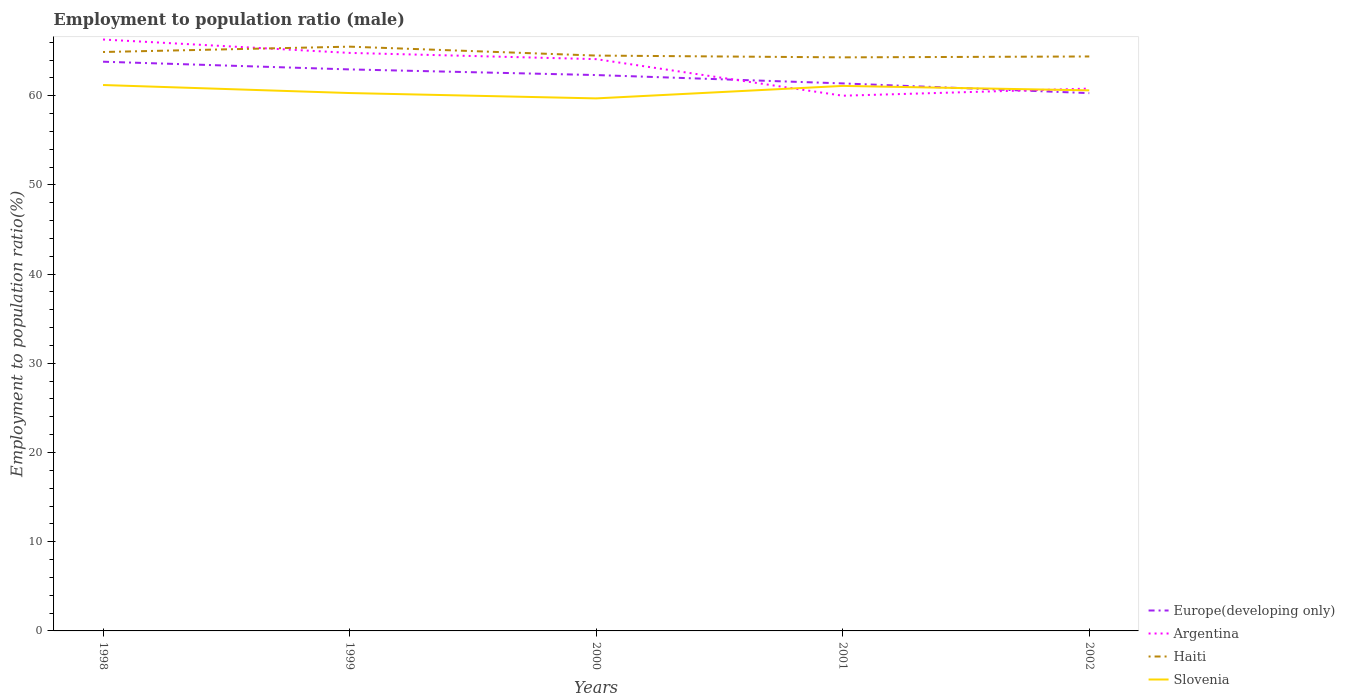How many different coloured lines are there?
Keep it short and to the point. 4. Does the line corresponding to Europe(developing only) intersect with the line corresponding to Haiti?
Provide a succinct answer. No. Across all years, what is the maximum employment to population ratio in Haiti?
Provide a short and direct response. 64.3. What is the total employment to population ratio in Haiti in the graph?
Offer a terse response. -0.6. What is the difference between the highest and the second highest employment to population ratio in Slovenia?
Give a very brief answer. 1.5. Is the employment to population ratio in Argentina strictly greater than the employment to population ratio in Haiti over the years?
Offer a very short reply. No. How many years are there in the graph?
Keep it short and to the point. 5. Does the graph contain any zero values?
Provide a short and direct response. No. Does the graph contain grids?
Ensure brevity in your answer.  No. How many legend labels are there?
Give a very brief answer. 4. How are the legend labels stacked?
Ensure brevity in your answer.  Vertical. What is the title of the graph?
Your answer should be compact. Employment to population ratio (male). Does "Russian Federation" appear as one of the legend labels in the graph?
Provide a succinct answer. No. What is the label or title of the X-axis?
Offer a very short reply. Years. What is the Employment to population ratio(%) of Europe(developing only) in 1998?
Provide a succinct answer. 63.81. What is the Employment to population ratio(%) of Argentina in 1998?
Offer a very short reply. 66.3. What is the Employment to population ratio(%) in Haiti in 1998?
Offer a very short reply. 64.9. What is the Employment to population ratio(%) in Slovenia in 1998?
Your response must be concise. 61.2. What is the Employment to population ratio(%) in Europe(developing only) in 1999?
Your response must be concise. 62.95. What is the Employment to population ratio(%) in Argentina in 1999?
Give a very brief answer. 64.8. What is the Employment to population ratio(%) of Haiti in 1999?
Provide a short and direct response. 65.5. What is the Employment to population ratio(%) of Slovenia in 1999?
Your answer should be very brief. 60.3. What is the Employment to population ratio(%) of Europe(developing only) in 2000?
Your response must be concise. 62.32. What is the Employment to population ratio(%) of Argentina in 2000?
Make the answer very short. 64.1. What is the Employment to population ratio(%) of Haiti in 2000?
Make the answer very short. 64.5. What is the Employment to population ratio(%) of Slovenia in 2000?
Provide a succinct answer. 59.7. What is the Employment to population ratio(%) of Europe(developing only) in 2001?
Your response must be concise. 61.38. What is the Employment to population ratio(%) of Haiti in 2001?
Offer a terse response. 64.3. What is the Employment to population ratio(%) of Slovenia in 2001?
Ensure brevity in your answer.  61.1. What is the Employment to population ratio(%) in Europe(developing only) in 2002?
Your answer should be compact. 60.29. What is the Employment to population ratio(%) in Argentina in 2002?
Your answer should be compact. 60.8. What is the Employment to population ratio(%) of Haiti in 2002?
Give a very brief answer. 64.4. What is the Employment to population ratio(%) in Slovenia in 2002?
Make the answer very short. 60.6. Across all years, what is the maximum Employment to population ratio(%) in Europe(developing only)?
Give a very brief answer. 63.81. Across all years, what is the maximum Employment to population ratio(%) of Argentina?
Keep it short and to the point. 66.3. Across all years, what is the maximum Employment to population ratio(%) of Haiti?
Your answer should be very brief. 65.5. Across all years, what is the maximum Employment to population ratio(%) in Slovenia?
Make the answer very short. 61.2. Across all years, what is the minimum Employment to population ratio(%) of Europe(developing only)?
Your response must be concise. 60.29. Across all years, what is the minimum Employment to population ratio(%) in Argentina?
Offer a very short reply. 60. Across all years, what is the minimum Employment to population ratio(%) in Haiti?
Offer a very short reply. 64.3. Across all years, what is the minimum Employment to population ratio(%) of Slovenia?
Offer a terse response. 59.7. What is the total Employment to population ratio(%) of Europe(developing only) in the graph?
Offer a terse response. 310.75. What is the total Employment to population ratio(%) in Argentina in the graph?
Your response must be concise. 316. What is the total Employment to population ratio(%) of Haiti in the graph?
Offer a very short reply. 323.6. What is the total Employment to population ratio(%) of Slovenia in the graph?
Offer a terse response. 302.9. What is the difference between the Employment to population ratio(%) of Europe(developing only) in 1998 and that in 1999?
Keep it short and to the point. 0.86. What is the difference between the Employment to population ratio(%) in Haiti in 1998 and that in 1999?
Your answer should be compact. -0.6. What is the difference between the Employment to population ratio(%) of Europe(developing only) in 1998 and that in 2000?
Keep it short and to the point. 1.5. What is the difference between the Employment to population ratio(%) in Argentina in 1998 and that in 2000?
Make the answer very short. 2.2. What is the difference between the Employment to population ratio(%) of Europe(developing only) in 1998 and that in 2001?
Give a very brief answer. 2.43. What is the difference between the Employment to population ratio(%) of Argentina in 1998 and that in 2001?
Make the answer very short. 6.3. What is the difference between the Employment to population ratio(%) in Haiti in 1998 and that in 2001?
Your response must be concise. 0.6. What is the difference between the Employment to population ratio(%) of Slovenia in 1998 and that in 2001?
Provide a succinct answer. 0.1. What is the difference between the Employment to population ratio(%) of Europe(developing only) in 1998 and that in 2002?
Your response must be concise. 3.52. What is the difference between the Employment to population ratio(%) of Argentina in 1998 and that in 2002?
Make the answer very short. 5.5. What is the difference between the Employment to population ratio(%) of Europe(developing only) in 1999 and that in 2000?
Offer a terse response. 0.63. What is the difference between the Employment to population ratio(%) of Argentina in 1999 and that in 2000?
Provide a succinct answer. 0.7. What is the difference between the Employment to population ratio(%) of Europe(developing only) in 1999 and that in 2001?
Keep it short and to the point. 1.57. What is the difference between the Employment to population ratio(%) of Argentina in 1999 and that in 2001?
Offer a terse response. 4.8. What is the difference between the Employment to population ratio(%) of Slovenia in 1999 and that in 2001?
Offer a terse response. -0.8. What is the difference between the Employment to population ratio(%) in Europe(developing only) in 1999 and that in 2002?
Ensure brevity in your answer.  2.66. What is the difference between the Employment to population ratio(%) of Argentina in 1999 and that in 2002?
Your answer should be very brief. 4. What is the difference between the Employment to population ratio(%) of Haiti in 1999 and that in 2002?
Provide a succinct answer. 1.1. What is the difference between the Employment to population ratio(%) of Europe(developing only) in 2000 and that in 2001?
Provide a short and direct response. 0.94. What is the difference between the Employment to population ratio(%) of Argentina in 2000 and that in 2001?
Offer a terse response. 4.1. What is the difference between the Employment to population ratio(%) in Haiti in 2000 and that in 2001?
Your answer should be very brief. 0.2. What is the difference between the Employment to population ratio(%) of Slovenia in 2000 and that in 2001?
Make the answer very short. -1.4. What is the difference between the Employment to population ratio(%) in Europe(developing only) in 2000 and that in 2002?
Your answer should be compact. 2.03. What is the difference between the Employment to population ratio(%) of Argentina in 2000 and that in 2002?
Offer a very short reply. 3.3. What is the difference between the Employment to population ratio(%) in Haiti in 2000 and that in 2002?
Keep it short and to the point. 0.1. What is the difference between the Employment to population ratio(%) of Slovenia in 2000 and that in 2002?
Your answer should be compact. -0.9. What is the difference between the Employment to population ratio(%) of Europe(developing only) in 2001 and that in 2002?
Ensure brevity in your answer.  1.09. What is the difference between the Employment to population ratio(%) in Argentina in 2001 and that in 2002?
Offer a very short reply. -0.8. What is the difference between the Employment to population ratio(%) in Haiti in 2001 and that in 2002?
Ensure brevity in your answer.  -0.1. What is the difference between the Employment to population ratio(%) in Slovenia in 2001 and that in 2002?
Provide a short and direct response. 0.5. What is the difference between the Employment to population ratio(%) in Europe(developing only) in 1998 and the Employment to population ratio(%) in Argentina in 1999?
Make the answer very short. -0.99. What is the difference between the Employment to population ratio(%) of Europe(developing only) in 1998 and the Employment to population ratio(%) of Haiti in 1999?
Offer a terse response. -1.69. What is the difference between the Employment to population ratio(%) of Europe(developing only) in 1998 and the Employment to population ratio(%) of Slovenia in 1999?
Your response must be concise. 3.51. What is the difference between the Employment to population ratio(%) in Europe(developing only) in 1998 and the Employment to population ratio(%) in Argentina in 2000?
Offer a terse response. -0.29. What is the difference between the Employment to population ratio(%) in Europe(developing only) in 1998 and the Employment to population ratio(%) in Haiti in 2000?
Your answer should be compact. -0.69. What is the difference between the Employment to population ratio(%) in Europe(developing only) in 1998 and the Employment to population ratio(%) in Slovenia in 2000?
Ensure brevity in your answer.  4.11. What is the difference between the Employment to population ratio(%) of Europe(developing only) in 1998 and the Employment to population ratio(%) of Argentina in 2001?
Give a very brief answer. 3.81. What is the difference between the Employment to population ratio(%) of Europe(developing only) in 1998 and the Employment to population ratio(%) of Haiti in 2001?
Your answer should be very brief. -0.49. What is the difference between the Employment to population ratio(%) of Europe(developing only) in 1998 and the Employment to population ratio(%) of Slovenia in 2001?
Your answer should be very brief. 2.71. What is the difference between the Employment to population ratio(%) in Argentina in 1998 and the Employment to population ratio(%) in Haiti in 2001?
Offer a terse response. 2. What is the difference between the Employment to population ratio(%) in Europe(developing only) in 1998 and the Employment to population ratio(%) in Argentina in 2002?
Provide a short and direct response. 3.01. What is the difference between the Employment to population ratio(%) of Europe(developing only) in 1998 and the Employment to population ratio(%) of Haiti in 2002?
Keep it short and to the point. -0.59. What is the difference between the Employment to population ratio(%) in Europe(developing only) in 1998 and the Employment to population ratio(%) in Slovenia in 2002?
Offer a very short reply. 3.21. What is the difference between the Employment to population ratio(%) of Argentina in 1998 and the Employment to population ratio(%) of Slovenia in 2002?
Provide a short and direct response. 5.7. What is the difference between the Employment to population ratio(%) in Haiti in 1998 and the Employment to population ratio(%) in Slovenia in 2002?
Give a very brief answer. 4.3. What is the difference between the Employment to population ratio(%) of Europe(developing only) in 1999 and the Employment to population ratio(%) of Argentina in 2000?
Your answer should be very brief. -1.15. What is the difference between the Employment to population ratio(%) in Europe(developing only) in 1999 and the Employment to population ratio(%) in Haiti in 2000?
Your answer should be very brief. -1.55. What is the difference between the Employment to population ratio(%) in Europe(developing only) in 1999 and the Employment to population ratio(%) in Slovenia in 2000?
Your answer should be compact. 3.25. What is the difference between the Employment to population ratio(%) in Argentina in 1999 and the Employment to population ratio(%) in Haiti in 2000?
Offer a terse response. 0.3. What is the difference between the Employment to population ratio(%) of Argentina in 1999 and the Employment to population ratio(%) of Slovenia in 2000?
Make the answer very short. 5.1. What is the difference between the Employment to population ratio(%) of Haiti in 1999 and the Employment to population ratio(%) of Slovenia in 2000?
Your answer should be compact. 5.8. What is the difference between the Employment to population ratio(%) in Europe(developing only) in 1999 and the Employment to population ratio(%) in Argentina in 2001?
Ensure brevity in your answer.  2.95. What is the difference between the Employment to population ratio(%) of Europe(developing only) in 1999 and the Employment to population ratio(%) of Haiti in 2001?
Give a very brief answer. -1.35. What is the difference between the Employment to population ratio(%) of Europe(developing only) in 1999 and the Employment to population ratio(%) of Slovenia in 2001?
Offer a very short reply. 1.85. What is the difference between the Employment to population ratio(%) of Argentina in 1999 and the Employment to population ratio(%) of Haiti in 2001?
Your answer should be very brief. 0.5. What is the difference between the Employment to population ratio(%) of Europe(developing only) in 1999 and the Employment to population ratio(%) of Argentina in 2002?
Your response must be concise. 2.15. What is the difference between the Employment to population ratio(%) of Europe(developing only) in 1999 and the Employment to population ratio(%) of Haiti in 2002?
Your answer should be very brief. -1.45. What is the difference between the Employment to population ratio(%) in Europe(developing only) in 1999 and the Employment to population ratio(%) in Slovenia in 2002?
Ensure brevity in your answer.  2.35. What is the difference between the Employment to population ratio(%) of Argentina in 1999 and the Employment to population ratio(%) of Haiti in 2002?
Provide a short and direct response. 0.4. What is the difference between the Employment to population ratio(%) of Haiti in 1999 and the Employment to population ratio(%) of Slovenia in 2002?
Provide a short and direct response. 4.9. What is the difference between the Employment to population ratio(%) of Europe(developing only) in 2000 and the Employment to population ratio(%) of Argentina in 2001?
Provide a short and direct response. 2.32. What is the difference between the Employment to population ratio(%) of Europe(developing only) in 2000 and the Employment to population ratio(%) of Haiti in 2001?
Provide a short and direct response. -1.98. What is the difference between the Employment to population ratio(%) of Europe(developing only) in 2000 and the Employment to population ratio(%) of Slovenia in 2001?
Ensure brevity in your answer.  1.22. What is the difference between the Employment to population ratio(%) of Europe(developing only) in 2000 and the Employment to population ratio(%) of Argentina in 2002?
Give a very brief answer. 1.52. What is the difference between the Employment to population ratio(%) of Europe(developing only) in 2000 and the Employment to population ratio(%) of Haiti in 2002?
Keep it short and to the point. -2.08. What is the difference between the Employment to population ratio(%) of Europe(developing only) in 2000 and the Employment to population ratio(%) of Slovenia in 2002?
Make the answer very short. 1.72. What is the difference between the Employment to population ratio(%) of Argentina in 2000 and the Employment to population ratio(%) of Haiti in 2002?
Your answer should be very brief. -0.3. What is the difference between the Employment to population ratio(%) in Argentina in 2000 and the Employment to population ratio(%) in Slovenia in 2002?
Provide a succinct answer. 3.5. What is the difference between the Employment to population ratio(%) of Europe(developing only) in 2001 and the Employment to population ratio(%) of Argentina in 2002?
Give a very brief answer. 0.58. What is the difference between the Employment to population ratio(%) in Europe(developing only) in 2001 and the Employment to population ratio(%) in Haiti in 2002?
Provide a short and direct response. -3.02. What is the difference between the Employment to population ratio(%) in Europe(developing only) in 2001 and the Employment to population ratio(%) in Slovenia in 2002?
Provide a short and direct response. 0.78. What is the difference between the Employment to population ratio(%) in Argentina in 2001 and the Employment to population ratio(%) in Haiti in 2002?
Offer a very short reply. -4.4. What is the average Employment to population ratio(%) of Europe(developing only) per year?
Ensure brevity in your answer.  62.15. What is the average Employment to population ratio(%) in Argentina per year?
Ensure brevity in your answer.  63.2. What is the average Employment to population ratio(%) in Haiti per year?
Your answer should be very brief. 64.72. What is the average Employment to population ratio(%) of Slovenia per year?
Your answer should be very brief. 60.58. In the year 1998, what is the difference between the Employment to population ratio(%) of Europe(developing only) and Employment to population ratio(%) of Argentina?
Your answer should be very brief. -2.49. In the year 1998, what is the difference between the Employment to population ratio(%) in Europe(developing only) and Employment to population ratio(%) in Haiti?
Keep it short and to the point. -1.09. In the year 1998, what is the difference between the Employment to population ratio(%) in Europe(developing only) and Employment to population ratio(%) in Slovenia?
Ensure brevity in your answer.  2.61. In the year 1998, what is the difference between the Employment to population ratio(%) in Argentina and Employment to population ratio(%) in Haiti?
Offer a very short reply. 1.4. In the year 1999, what is the difference between the Employment to population ratio(%) in Europe(developing only) and Employment to population ratio(%) in Argentina?
Your answer should be very brief. -1.85. In the year 1999, what is the difference between the Employment to population ratio(%) of Europe(developing only) and Employment to population ratio(%) of Haiti?
Give a very brief answer. -2.55. In the year 1999, what is the difference between the Employment to population ratio(%) of Europe(developing only) and Employment to population ratio(%) of Slovenia?
Offer a very short reply. 2.65. In the year 1999, what is the difference between the Employment to population ratio(%) of Argentina and Employment to population ratio(%) of Haiti?
Give a very brief answer. -0.7. In the year 1999, what is the difference between the Employment to population ratio(%) of Argentina and Employment to population ratio(%) of Slovenia?
Provide a succinct answer. 4.5. In the year 1999, what is the difference between the Employment to population ratio(%) of Haiti and Employment to population ratio(%) of Slovenia?
Your response must be concise. 5.2. In the year 2000, what is the difference between the Employment to population ratio(%) of Europe(developing only) and Employment to population ratio(%) of Argentina?
Your answer should be very brief. -1.78. In the year 2000, what is the difference between the Employment to population ratio(%) of Europe(developing only) and Employment to population ratio(%) of Haiti?
Offer a terse response. -2.18. In the year 2000, what is the difference between the Employment to population ratio(%) of Europe(developing only) and Employment to population ratio(%) of Slovenia?
Offer a terse response. 2.62. In the year 2000, what is the difference between the Employment to population ratio(%) of Argentina and Employment to population ratio(%) of Slovenia?
Your answer should be very brief. 4.4. In the year 2000, what is the difference between the Employment to population ratio(%) in Haiti and Employment to population ratio(%) in Slovenia?
Keep it short and to the point. 4.8. In the year 2001, what is the difference between the Employment to population ratio(%) of Europe(developing only) and Employment to population ratio(%) of Argentina?
Your answer should be very brief. 1.38. In the year 2001, what is the difference between the Employment to population ratio(%) of Europe(developing only) and Employment to population ratio(%) of Haiti?
Keep it short and to the point. -2.92. In the year 2001, what is the difference between the Employment to population ratio(%) in Europe(developing only) and Employment to population ratio(%) in Slovenia?
Offer a very short reply. 0.28. In the year 2001, what is the difference between the Employment to population ratio(%) in Haiti and Employment to population ratio(%) in Slovenia?
Ensure brevity in your answer.  3.2. In the year 2002, what is the difference between the Employment to population ratio(%) in Europe(developing only) and Employment to population ratio(%) in Argentina?
Make the answer very short. -0.51. In the year 2002, what is the difference between the Employment to population ratio(%) of Europe(developing only) and Employment to population ratio(%) of Haiti?
Provide a succinct answer. -4.11. In the year 2002, what is the difference between the Employment to population ratio(%) in Europe(developing only) and Employment to population ratio(%) in Slovenia?
Offer a very short reply. -0.31. In the year 2002, what is the difference between the Employment to population ratio(%) in Argentina and Employment to population ratio(%) in Haiti?
Make the answer very short. -3.6. In the year 2002, what is the difference between the Employment to population ratio(%) in Argentina and Employment to population ratio(%) in Slovenia?
Offer a very short reply. 0.2. What is the ratio of the Employment to population ratio(%) in Europe(developing only) in 1998 to that in 1999?
Offer a terse response. 1.01. What is the ratio of the Employment to population ratio(%) of Argentina in 1998 to that in 1999?
Ensure brevity in your answer.  1.02. What is the ratio of the Employment to population ratio(%) in Slovenia in 1998 to that in 1999?
Make the answer very short. 1.01. What is the ratio of the Employment to population ratio(%) of Argentina in 1998 to that in 2000?
Your answer should be compact. 1.03. What is the ratio of the Employment to population ratio(%) of Haiti in 1998 to that in 2000?
Offer a terse response. 1.01. What is the ratio of the Employment to population ratio(%) in Slovenia in 1998 to that in 2000?
Your response must be concise. 1.03. What is the ratio of the Employment to population ratio(%) in Europe(developing only) in 1998 to that in 2001?
Make the answer very short. 1.04. What is the ratio of the Employment to population ratio(%) of Argentina in 1998 to that in 2001?
Make the answer very short. 1.1. What is the ratio of the Employment to population ratio(%) in Haiti in 1998 to that in 2001?
Your answer should be compact. 1.01. What is the ratio of the Employment to population ratio(%) in Slovenia in 1998 to that in 2001?
Offer a terse response. 1. What is the ratio of the Employment to population ratio(%) of Europe(developing only) in 1998 to that in 2002?
Your response must be concise. 1.06. What is the ratio of the Employment to population ratio(%) in Argentina in 1998 to that in 2002?
Your response must be concise. 1.09. What is the ratio of the Employment to population ratio(%) in Slovenia in 1998 to that in 2002?
Make the answer very short. 1.01. What is the ratio of the Employment to population ratio(%) in Europe(developing only) in 1999 to that in 2000?
Your response must be concise. 1.01. What is the ratio of the Employment to population ratio(%) of Argentina in 1999 to that in 2000?
Your answer should be very brief. 1.01. What is the ratio of the Employment to population ratio(%) of Haiti in 1999 to that in 2000?
Offer a terse response. 1.02. What is the ratio of the Employment to population ratio(%) of Europe(developing only) in 1999 to that in 2001?
Offer a very short reply. 1.03. What is the ratio of the Employment to population ratio(%) in Haiti in 1999 to that in 2001?
Offer a terse response. 1.02. What is the ratio of the Employment to population ratio(%) of Slovenia in 1999 to that in 2001?
Keep it short and to the point. 0.99. What is the ratio of the Employment to population ratio(%) of Europe(developing only) in 1999 to that in 2002?
Ensure brevity in your answer.  1.04. What is the ratio of the Employment to population ratio(%) of Argentina in 1999 to that in 2002?
Your answer should be compact. 1.07. What is the ratio of the Employment to population ratio(%) in Haiti in 1999 to that in 2002?
Your answer should be very brief. 1.02. What is the ratio of the Employment to population ratio(%) in Europe(developing only) in 2000 to that in 2001?
Your response must be concise. 1.02. What is the ratio of the Employment to population ratio(%) in Argentina in 2000 to that in 2001?
Make the answer very short. 1.07. What is the ratio of the Employment to population ratio(%) of Slovenia in 2000 to that in 2001?
Keep it short and to the point. 0.98. What is the ratio of the Employment to population ratio(%) in Europe(developing only) in 2000 to that in 2002?
Your response must be concise. 1.03. What is the ratio of the Employment to population ratio(%) in Argentina in 2000 to that in 2002?
Keep it short and to the point. 1.05. What is the ratio of the Employment to population ratio(%) in Slovenia in 2000 to that in 2002?
Provide a succinct answer. 0.99. What is the ratio of the Employment to population ratio(%) of Europe(developing only) in 2001 to that in 2002?
Offer a very short reply. 1.02. What is the ratio of the Employment to population ratio(%) of Argentina in 2001 to that in 2002?
Make the answer very short. 0.99. What is the ratio of the Employment to population ratio(%) in Slovenia in 2001 to that in 2002?
Provide a short and direct response. 1.01. What is the difference between the highest and the second highest Employment to population ratio(%) in Europe(developing only)?
Keep it short and to the point. 0.86. What is the difference between the highest and the second highest Employment to population ratio(%) in Haiti?
Ensure brevity in your answer.  0.6. What is the difference between the highest and the lowest Employment to population ratio(%) in Europe(developing only)?
Your answer should be very brief. 3.52. What is the difference between the highest and the lowest Employment to population ratio(%) in Argentina?
Ensure brevity in your answer.  6.3. What is the difference between the highest and the lowest Employment to population ratio(%) of Haiti?
Your response must be concise. 1.2. What is the difference between the highest and the lowest Employment to population ratio(%) in Slovenia?
Ensure brevity in your answer.  1.5. 